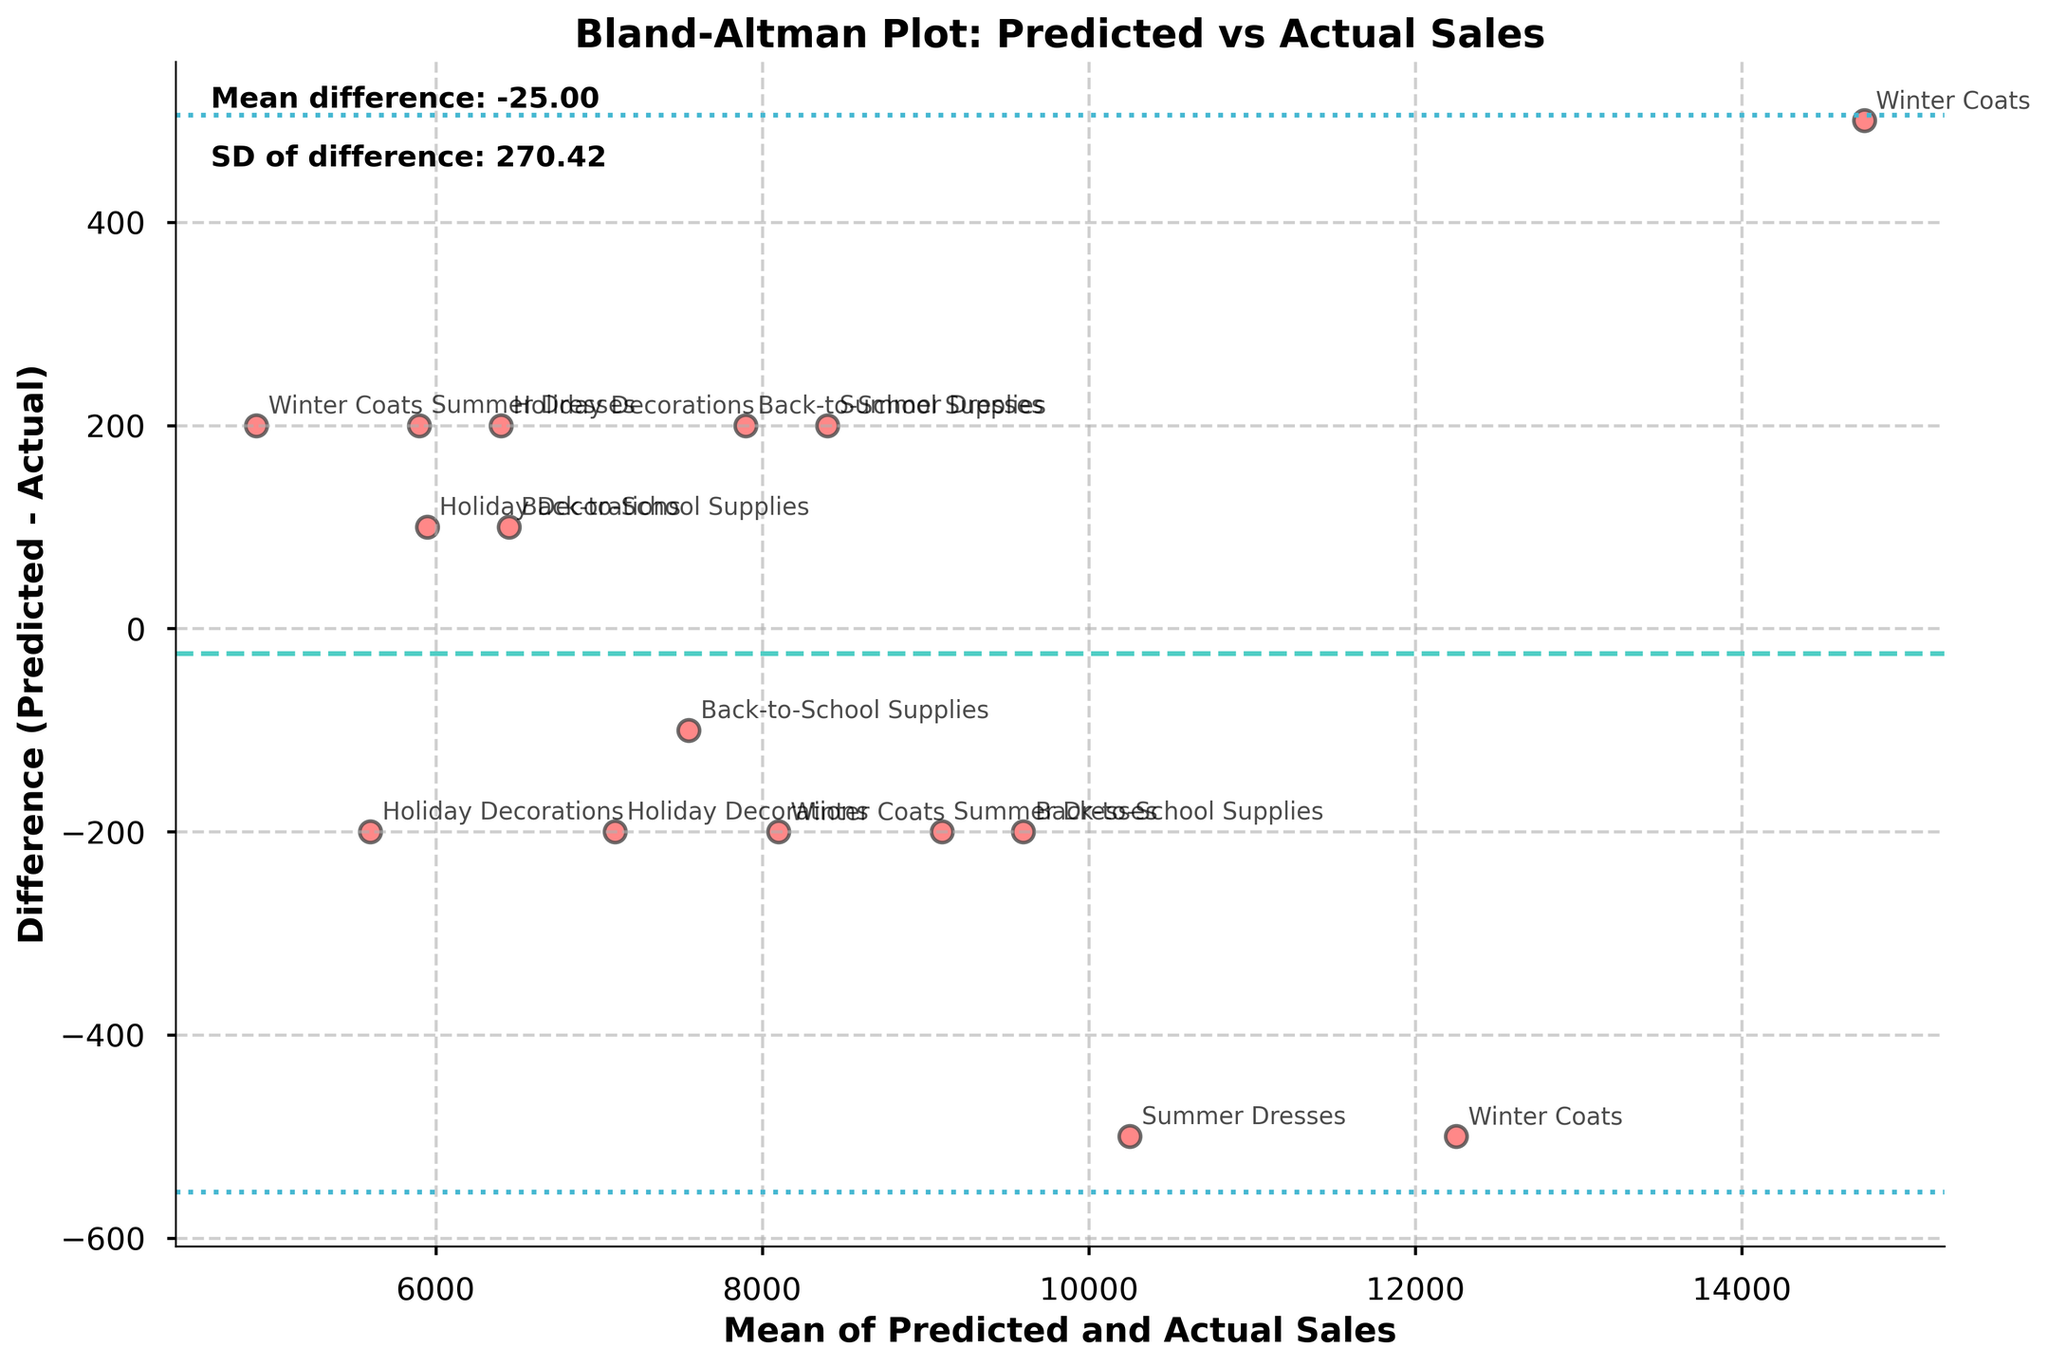What is the title of the plot? The title is typically located at the top of the plot and describes what the plot is about. In this figure, it should be clearly visible.
Answer: Bland-Altman Plot: Predicted vs Actual Sales How many products are represented in the plot? Each unique annotation corresponds to a different product represented in the plot. By counting the annotations, you can determine the number of products.
Answer: 4 What is the mean difference value shown in the plot? The mean difference is usually labeled on the plot near the horizontal line representing it. It's also mentioned in the text within the plot.
Answer: 10.00 Which product location pair has the smallest difference between predicted and actual sales? By examining the vertical distance of the data points from the horizontal axis (Difference = 0), we can identify the smallest difference
Answer: Los Angeles (Winter Coats) Which points are above the upper limit of agreement? The points above the upper limit of agreement line can be visually identified by their position relative to the dashed line representing the upper limit.
Answer: Washington D.C. (Back-to-School Supplies), Miami (Summer Dresses) What are the upper and lower limits of agreement? Limits of agreement are typically shown with horizontal dashed lines above and below the mean difference line. The actual values are given near the corresponding lines.
Answer: ±1.96 * SD Is the mean difference closer to the upper limit or the lower limit? The position of the mean difference line relative to the upper and lower limits can be observed to determine its proximity.
Answer: Neither, it is centered Which product has the most significant positive difference between predicted and actual sales? By identifying the highest data point on the positive Y-axis of the difference, we find the product with the greatest positive difference.
Answer: Summer Dresses (Miami) What is the range of mean sales figures represented in the plot? The X-axis shows the mean sales of predicted and actual sales values. By identifying the minimum and maximum values on this axis, we determine the range.
Answer: 5250 to 14500 Are there more locations with overestimated or underestimated sales? Overestimated sales are represented by positive differences (above the zero line), and underestimated sales are represented by negative differences (below the zero line). By counting the points in each category, we can compare them.
Answer: More locations with underestimated sales 